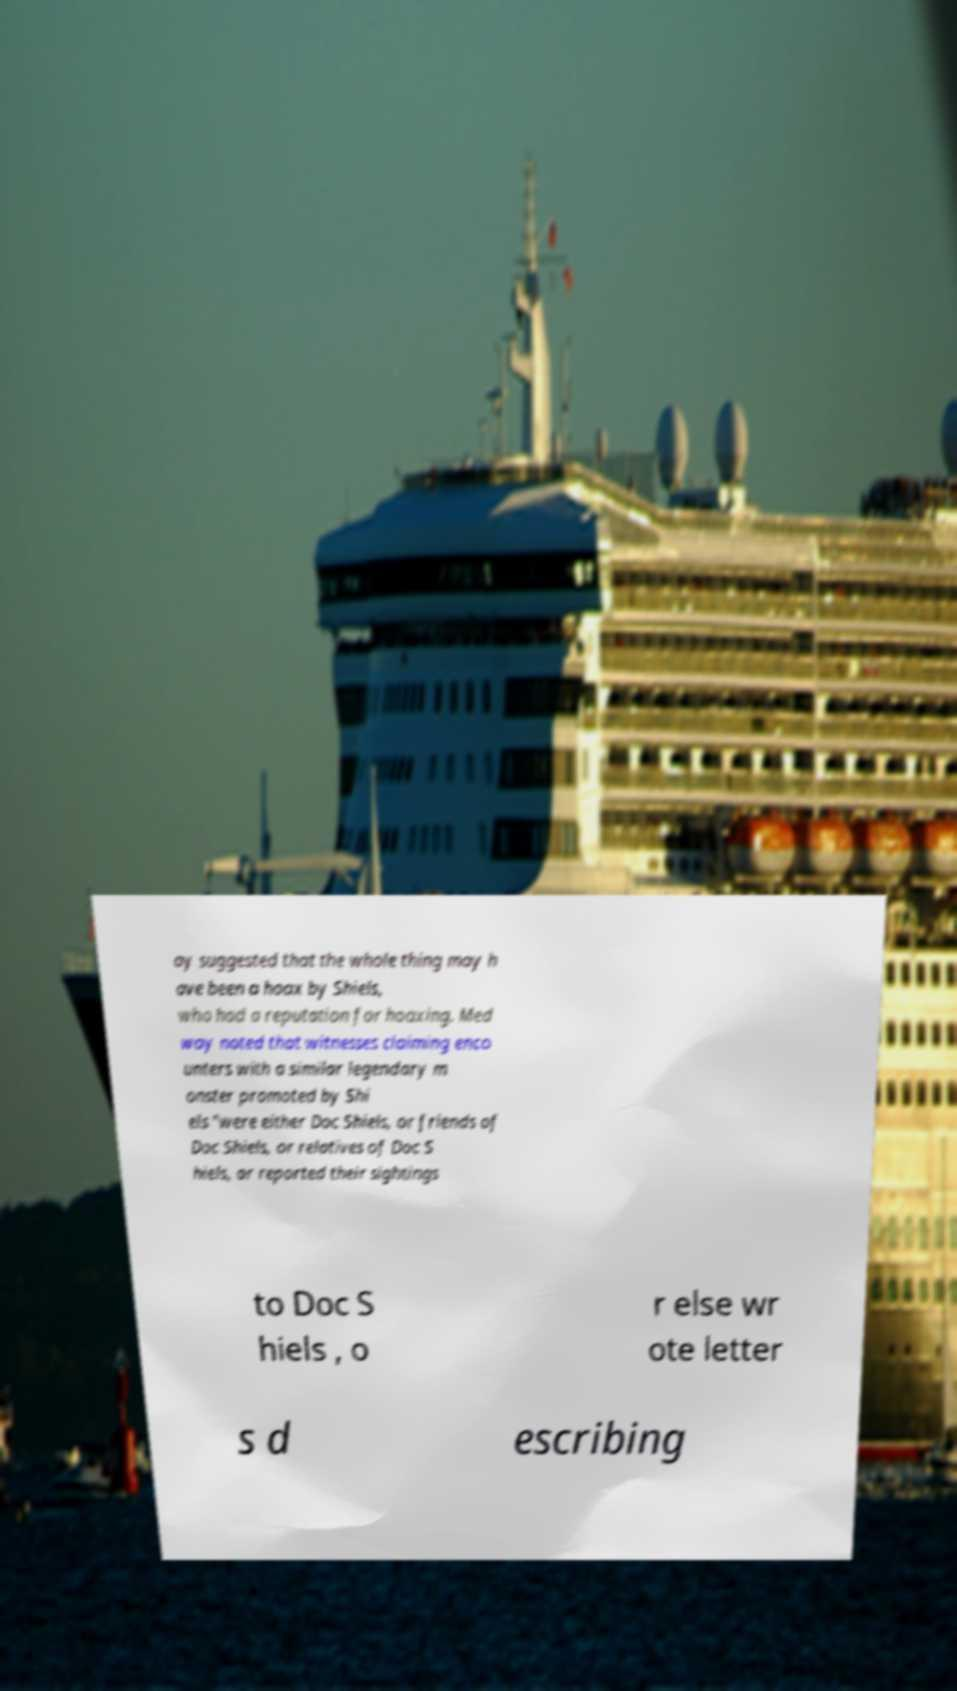Could you assist in decoding the text presented in this image and type it out clearly? ay suggested that the whole thing may h ave been a hoax by Shiels, who had a reputation for hoaxing. Med way noted that witnesses claiming enco unters with a similar legendary m onster promoted by Shi els "were either Doc Shiels, or friends of Doc Shiels, or relatives of Doc S hiels, or reported their sightings to Doc S hiels , o r else wr ote letter s d escribing 